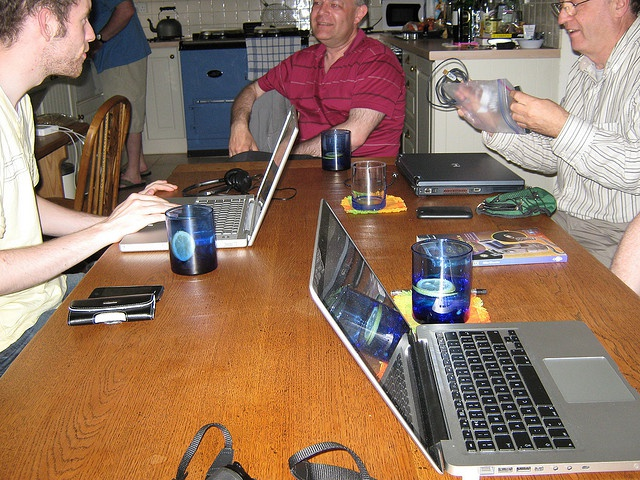Describe the objects in this image and their specific colors. I can see dining table in gray, brown, and black tones, laptop in gray, black, and darkgray tones, people in gray, white, lightpink, and tan tones, people in gray, lightgray, darkgray, and tan tones, and people in gray, brown, and maroon tones in this image. 